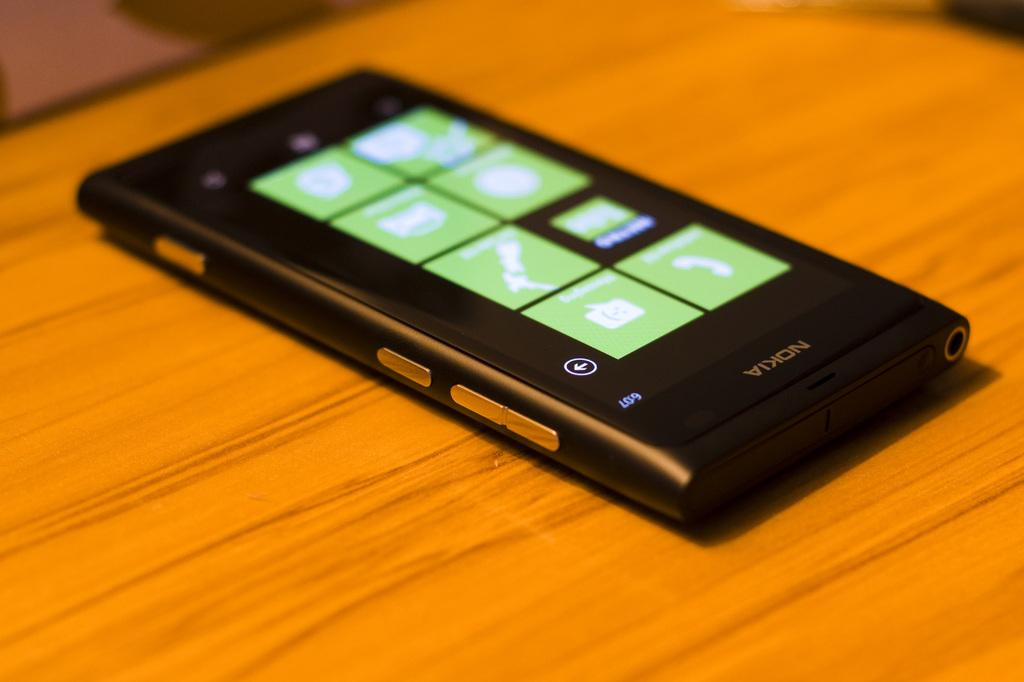<image>
Relay a brief, clear account of the picture shown. An older Nokia phone sitting on a wooden table. 